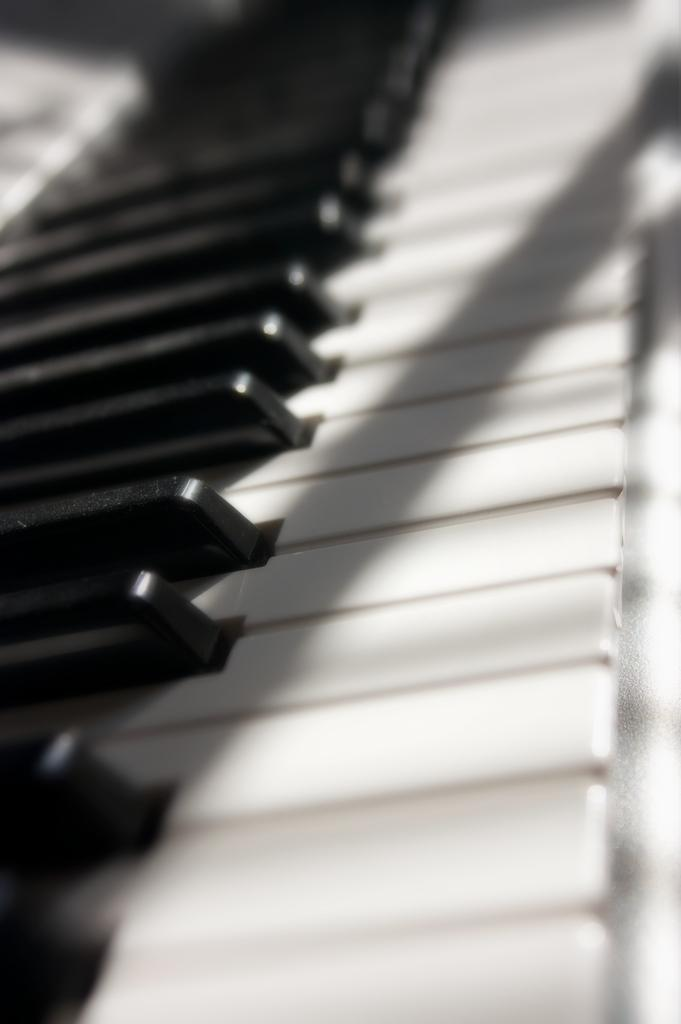What is the main object in the image? There is a keyboard in the image. What feature does the keyboard have? The keyboard has keys on it. What type of lunchroom is visible in the image? There is no lunchroom present in the image; it only features a keyboard. What is the interest of the men in the image? There are no men present in the image, so their interests cannot be determined. 